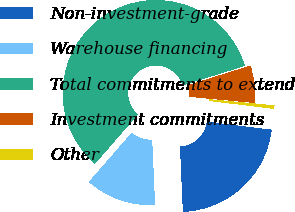Convert chart to OTSL. <chart><loc_0><loc_0><loc_500><loc_500><pie_chart><fcel>Non-investment-grade<fcel>Warehouse financing<fcel>Total commitments to extend<fcel>Investment commitments<fcel>Other<nl><fcel>22.32%<fcel>12.13%<fcel>58.77%<fcel>6.3%<fcel>0.47%<nl></chart> 